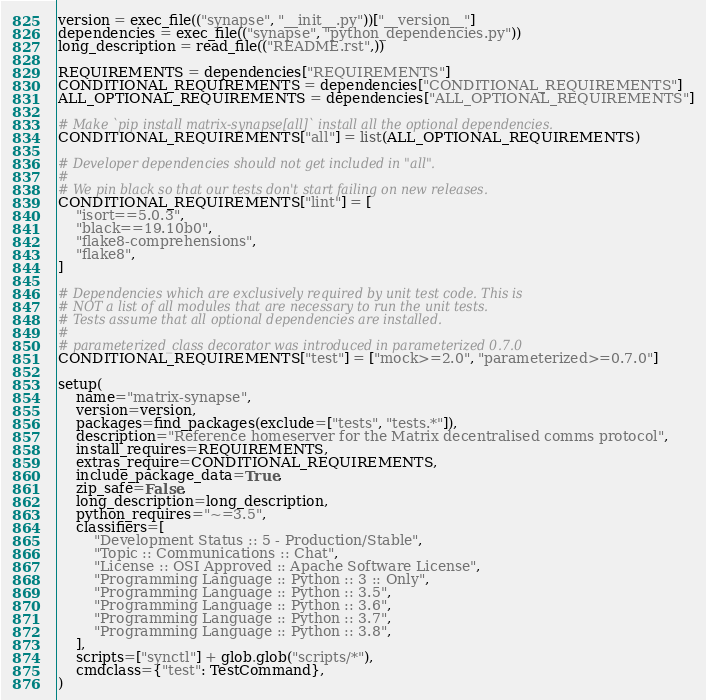<code> <loc_0><loc_0><loc_500><loc_500><_Python_>version = exec_file(("synapse", "__init__.py"))["__version__"]
dependencies = exec_file(("synapse", "python_dependencies.py"))
long_description = read_file(("README.rst",))

REQUIREMENTS = dependencies["REQUIREMENTS"]
CONDITIONAL_REQUIREMENTS = dependencies["CONDITIONAL_REQUIREMENTS"]
ALL_OPTIONAL_REQUIREMENTS = dependencies["ALL_OPTIONAL_REQUIREMENTS"]

# Make `pip install matrix-synapse[all]` install all the optional dependencies.
CONDITIONAL_REQUIREMENTS["all"] = list(ALL_OPTIONAL_REQUIREMENTS)

# Developer dependencies should not get included in "all".
#
# We pin black so that our tests don't start failing on new releases.
CONDITIONAL_REQUIREMENTS["lint"] = [
    "isort==5.0.3",
    "black==19.10b0",
    "flake8-comprehensions",
    "flake8",
]

# Dependencies which are exclusively required by unit test code. This is
# NOT a list of all modules that are necessary to run the unit tests.
# Tests assume that all optional dependencies are installed.
#
# parameterized_class decorator was introduced in parameterized 0.7.0
CONDITIONAL_REQUIREMENTS["test"] = ["mock>=2.0", "parameterized>=0.7.0"]

setup(
    name="matrix-synapse",
    version=version,
    packages=find_packages(exclude=["tests", "tests.*"]),
    description="Reference homeserver for the Matrix decentralised comms protocol",
    install_requires=REQUIREMENTS,
    extras_require=CONDITIONAL_REQUIREMENTS,
    include_package_data=True,
    zip_safe=False,
    long_description=long_description,
    python_requires="~=3.5",
    classifiers=[
        "Development Status :: 5 - Production/Stable",
        "Topic :: Communications :: Chat",
        "License :: OSI Approved :: Apache Software License",
        "Programming Language :: Python :: 3 :: Only",
        "Programming Language :: Python :: 3.5",
        "Programming Language :: Python :: 3.6",
        "Programming Language :: Python :: 3.7",
        "Programming Language :: Python :: 3.8",
    ],
    scripts=["synctl"] + glob.glob("scripts/*"),
    cmdclass={"test": TestCommand},
)
</code> 